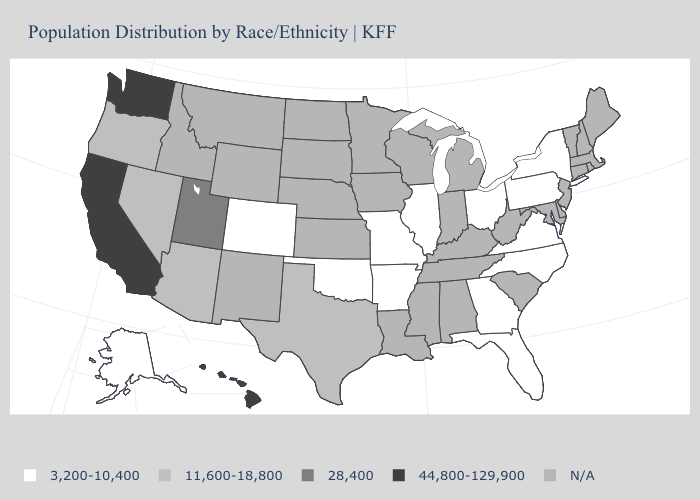What is the value of Rhode Island?
Keep it brief. N/A. What is the lowest value in the South?
Answer briefly. 3,200-10,400. Does the first symbol in the legend represent the smallest category?
Give a very brief answer. Yes. What is the value of Alabama?
Quick response, please. N/A. What is the value of Colorado?
Give a very brief answer. 3,200-10,400. Among the states that border Connecticut , which have the lowest value?
Quick response, please. New York. Does Texas have the lowest value in the South?
Quick response, please. No. What is the value of New Jersey?
Be succinct. N/A. Does the first symbol in the legend represent the smallest category?
Keep it brief. Yes. Does Hawaii have the highest value in the USA?
Quick response, please. Yes. What is the lowest value in the USA?
Keep it brief. 3,200-10,400. What is the value of Kentucky?
Keep it brief. N/A. Does the map have missing data?
Give a very brief answer. Yes. What is the value of Oregon?
Keep it brief. 11,600-18,800. Does Florida have the highest value in the USA?
Give a very brief answer. No. 